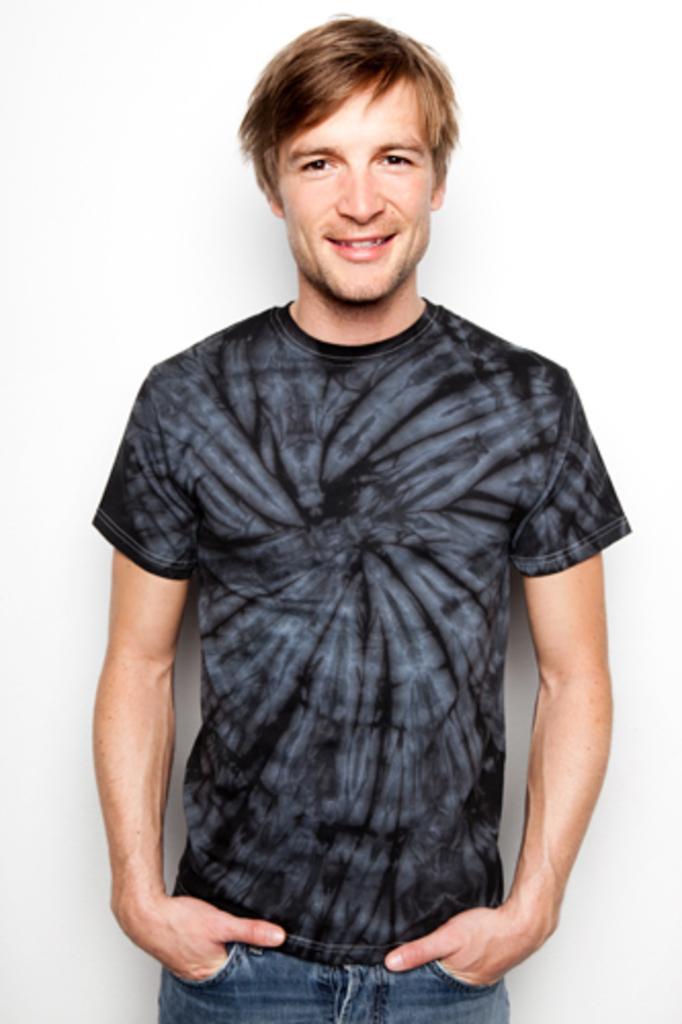How would you summarize this image in a sentence or two? In this image we can see a person standing and posing for a picture, look like there is a white colored wall behind him. 